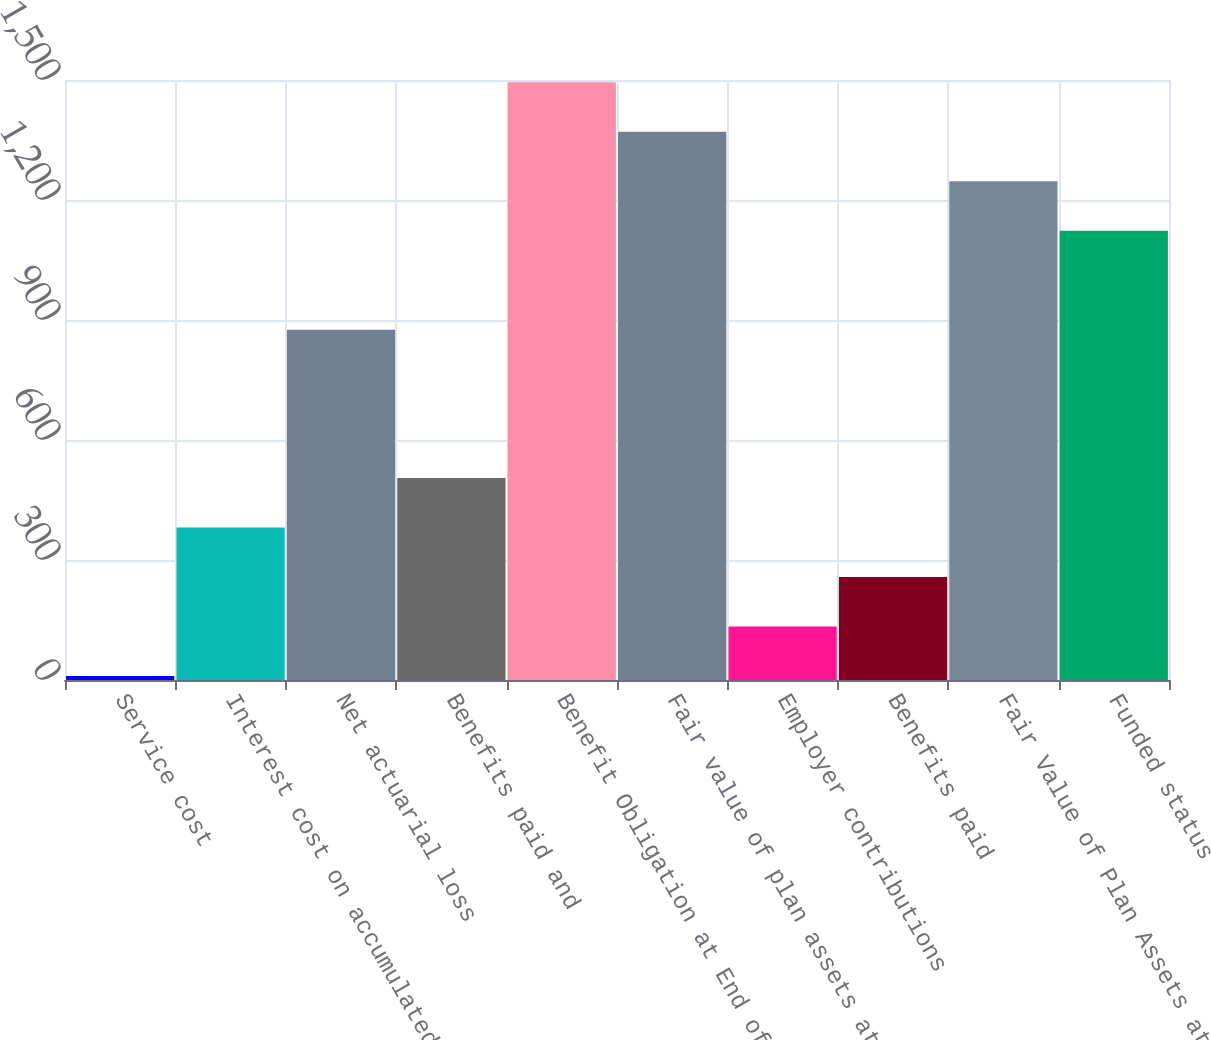Convert chart to OTSL. <chart><loc_0><loc_0><loc_500><loc_500><bar_chart><fcel>Service cost<fcel>Interest cost on accumulated<fcel>Net actuarial loss<fcel>Benefits paid and<fcel>Benefit Obligation at End of<fcel>Fair value of plan assets at<fcel>Employer contributions<fcel>Benefits paid<fcel>Fair Value of Plan Assets at<fcel>Funded status<nl><fcel>10<fcel>381.1<fcel>875.9<fcel>504.8<fcel>1494.4<fcel>1370.7<fcel>133.7<fcel>257.4<fcel>1247<fcel>1123.3<nl></chart> 